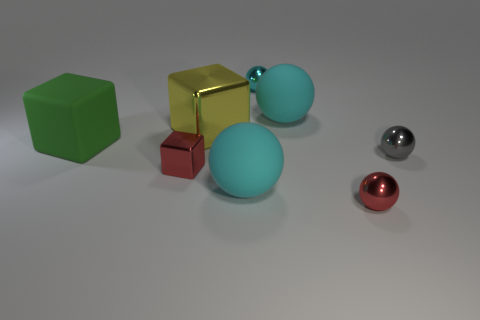Subtract all purple cubes. How many cyan spheres are left? 3 Subtract 1 spheres. How many spheres are left? 4 Subtract all gray spheres. How many spheres are left? 4 Subtract all cyan metallic spheres. How many spheres are left? 4 Subtract all yellow balls. Subtract all green cylinders. How many balls are left? 5 Add 1 small cyan shiny things. How many objects exist? 9 Subtract all balls. How many objects are left? 3 Add 4 small purple metal blocks. How many small purple metal blocks exist? 4 Subtract 1 red balls. How many objects are left? 7 Subtract all small gray balls. Subtract all big objects. How many objects are left? 3 